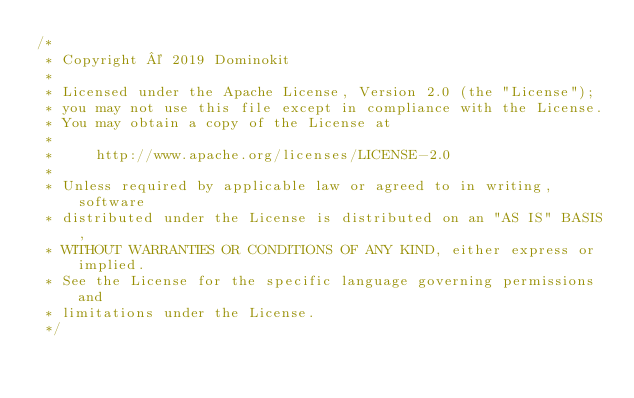Convert code to text. <code><loc_0><loc_0><loc_500><loc_500><_Java_>/*
 * Copyright © 2019 Dominokit
 *
 * Licensed under the Apache License, Version 2.0 (the "License");
 * you may not use this file except in compliance with the License.
 * You may obtain a copy of the License at
 *
 *     http://www.apache.org/licenses/LICENSE-2.0
 *
 * Unless required by applicable law or agreed to in writing, software
 * distributed under the License is distributed on an "AS IS" BASIS,
 * WITHOUT WARRANTIES OR CONDITIONS OF ANY KIND, either express or implied.
 * See the License for the specific language governing permissions and
 * limitations under the License.
 */</code> 